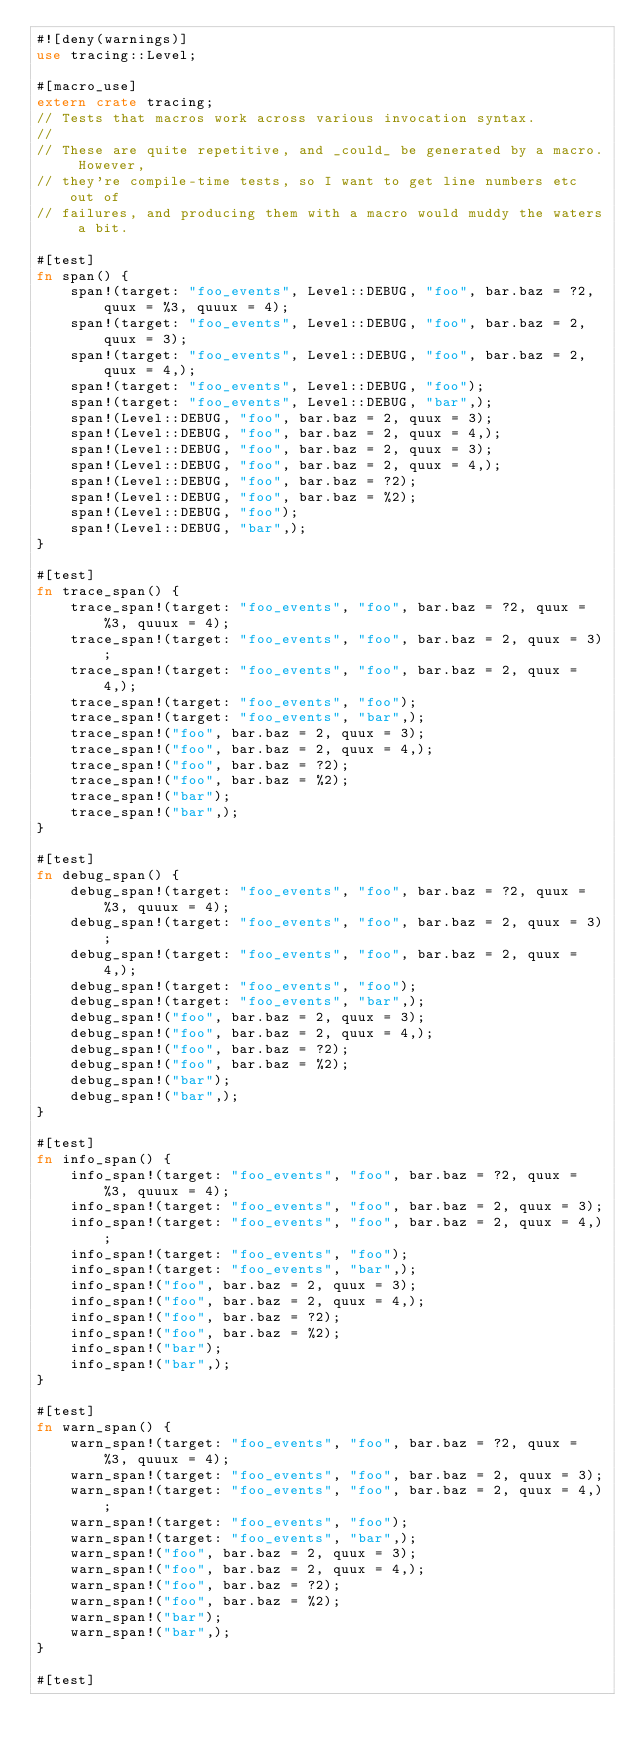Convert code to text. <code><loc_0><loc_0><loc_500><loc_500><_Rust_>#![deny(warnings)]
use tracing::Level;

#[macro_use]
extern crate tracing;
// Tests that macros work across various invocation syntax.
//
// These are quite repetitive, and _could_ be generated by a macro. However,
// they're compile-time tests, so I want to get line numbers etc out of
// failures, and producing them with a macro would muddy the waters a bit.

#[test]
fn span() {
    span!(target: "foo_events", Level::DEBUG, "foo", bar.baz = ?2, quux = %3, quuux = 4);
    span!(target: "foo_events", Level::DEBUG, "foo", bar.baz = 2, quux = 3);
    span!(target: "foo_events", Level::DEBUG, "foo", bar.baz = 2, quux = 4,);
    span!(target: "foo_events", Level::DEBUG, "foo");
    span!(target: "foo_events", Level::DEBUG, "bar",);
    span!(Level::DEBUG, "foo", bar.baz = 2, quux = 3);
    span!(Level::DEBUG, "foo", bar.baz = 2, quux = 4,);
    span!(Level::DEBUG, "foo", bar.baz = 2, quux = 3);
    span!(Level::DEBUG, "foo", bar.baz = 2, quux = 4,);
    span!(Level::DEBUG, "foo", bar.baz = ?2);
    span!(Level::DEBUG, "foo", bar.baz = %2);
    span!(Level::DEBUG, "foo");
    span!(Level::DEBUG, "bar",);
}

#[test]
fn trace_span() {
    trace_span!(target: "foo_events", "foo", bar.baz = ?2, quux = %3, quuux = 4);
    trace_span!(target: "foo_events", "foo", bar.baz = 2, quux = 3);
    trace_span!(target: "foo_events", "foo", bar.baz = 2, quux = 4,);
    trace_span!(target: "foo_events", "foo");
    trace_span!(target: "foo_events", "bar",);
    trace_span!("foo", bar.baz = 2, quux = 3);
    trace_span!("foo", bar.baz = 2, quux = 4,);
    trace_span!("foo", bar.baz = ?2);
    trace_span!("foo", bar.baz = %2);
    trace_span!("bar");
    trace_span!("bar",);
}

#[test]
fn debug_span() {
    debug_span!(target: "foo_events", "foo", bar.baz = ?2, quux = %3, quuux = 4);
    debug_span!(target: "foo_events", "foo", bar.baz = 2, quux = 3);
    debug_span!(target: "foo_events", "foo", bar.baz = 2, quux = 4,);
    debug_span!(target: "foo_events", "foo");
    debug_span!(target: "foo_events", "bar",);
    debug_span!("foo", bar.baz = 2, quux = 3);
    debug_span!("foo", bar.baz = 2, quux = 4,);
    debug_span!("foo", bar.baz = ?2);
    debug_span!("foo", bar.baz = %2);
    debug_span!("bar");
    debug_span!("bar",);
}

#[test]
fn info_span() {
    info_span!(target: "foo_events", "foo", bar.baz = ?2, quux = %3, quuux = 4);
    info_span!(target: "foo_events", "foo", bar.baz = 2, quux = 3);
    info_span!(target: "foo_events", "foo", bar.baz = 2, quux = 4,);
    info_span!(target: "foo_events", "foo");
    info_span!(target: "foo_events", "bar",);
    info_span!("foo", bar.baz = 2, quux = 3);
    info_span!("foo", bar.baz = 2, quux = 4,);
    info_span!("foo", bar.baz = ?2);
    info_span!("foo", bar.baz = %2);
    info_span!("bar");
    info_span!("bar",);
}

#[test]
fn warn_span() {
    warn_span!(target: "foo_events", "foo", bar.baz = ?2, quux = %3, quuux = 4);
    warn_span!(target: "foo_events", "foo", bar.baz = 2, quux = 3);
    warn_span!(target: "foo_events", "foo", bar.baz = 2, quux = 4,);
    warn_span!(target: "foo_events", "foo");
    warn_span!(target: "foo_events", "bar",);
    warn_span!("foo", bar.baz = 2, quux = 3);
    warn_span!("foo", bar.baz = 2, quux = 4,);
    warn_span!("foo", bar.baz = ?2);
    warn_span!("foo", bar.baz = %2);
    warn_span!("bar");
    warn_span!("bar",);
}

#[test]</code> 